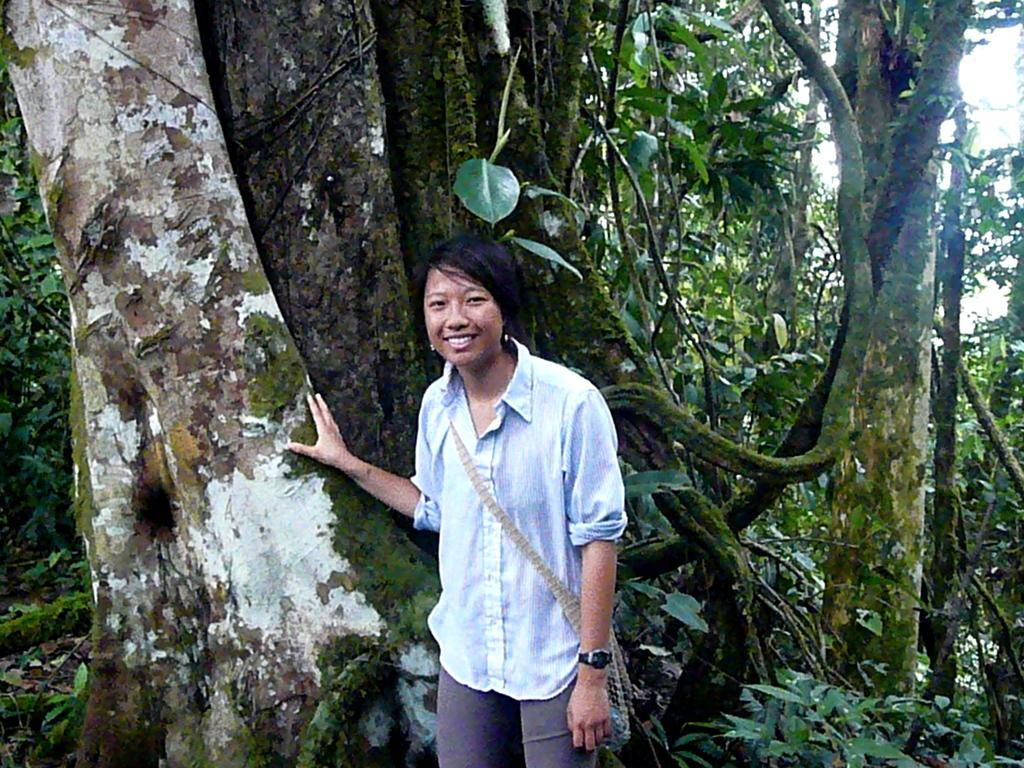Who is the main subject in the image? There is a lady in the image. Where is the lady positioned in the image? The lady is standing in the center of the image. What is the lady doing in the image? The lady is placing her hand on a tree trunk. What can be seen in the background of the image? There are trees in the background of the image. What type of butter is being used by the lady to climb the tree in the image? There is no butter present in the image, nor is the lady climbing the tree. 